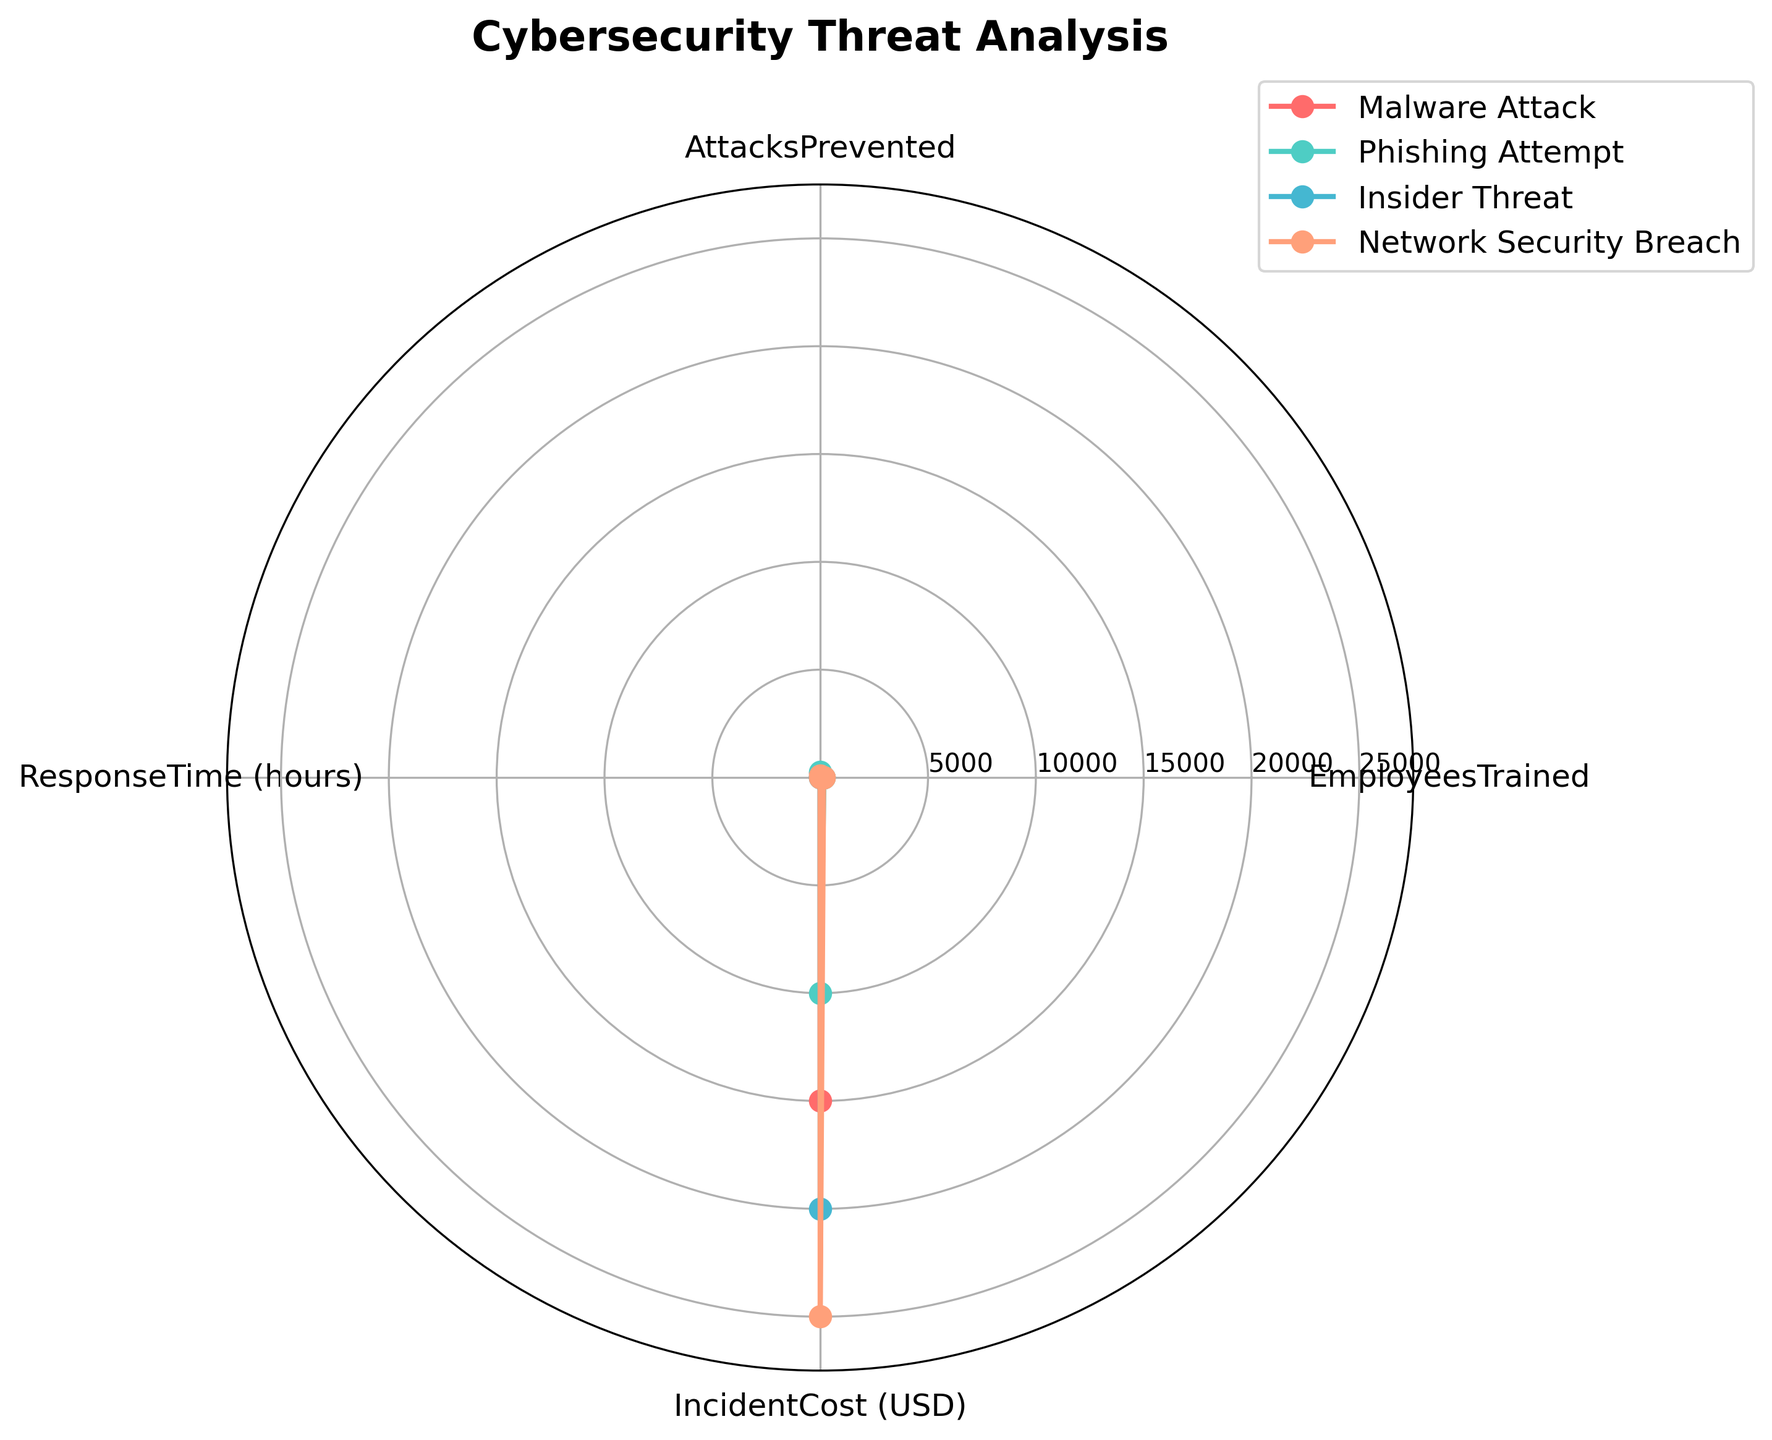What's the title of the figure? The title of the figure is usually found at the top of the chart. By looking at the rendered figure, you can note the title.
Answer: Cybersecurity Threat Analysis How many threat types are represented in the radar chart? The radar chart includes lines or shapes for each threat type, and each threat type is labeled in the legend. By counting these labels, you can determine the number of threat types.
Answer: 4 Which threat type has the highest number of employees trained? By looking at the "EmployeesTrained" axis and seeing which shape or line stretches the farthest towards the outer ring, we can identify the threat type.
Answer: Phishing Attempt What's the total incident cost for all threat types combined? To find the total incident cost, sum up the values of the "IncidentCost (USD)" axis for all threat types. The individual costs are 15000, 10000, 20000, and 25000.
Answer: 70000 Which threat type has the shortest response time? By checking the "ResponseTime (hours)" axis and identifying which threat type's data point is closest to the center (indicating the shortest response time), we can find the answer.
Answer: Phishing Attempt What's the average number of attacks prevented across all threat types? To find the average number of attacks prevented, sum up the attacks prevented by all threat types and divide by the number of threat types: (200 + 250 + 60 + 100) / 4 = 610 / 4.
Answer: 152.5 How does the number of attacks prevented for Malware Attack compare to Network Security Breach? Compare the values on the "AttacksPrevented" axis for these two threat types. Malware Attack = 200 and Network Security Breach = 100.
Answer: Malware Attack has more Which threat type has the highest incident cost, and how does it compare to the lowest incident cost threat type? Identify the threat type with the highest cost on the "IncidentCost (USD)" axis and compare it with the lowest. Highest is Network Security Breach = 25000, lowest is Phishing Attempt = 10000.
Answer: Network Security Breach is 15000 more than Phishing Attempt What is the difference in the number of employees trained between the Insider Threat and the Network Security Breach? Subtract the number of employees trained for Insider Threat from the number for Network Security Breach: 160 - 120.
Answer: 40 Which threat type has the lowest number of attacks prevented, and what does this imply about its relative impact compared to other threat types? By looking at the "AttacksPrevented" axis and identifying the lowest value (Insider Threat = 60), you can infer its relative impact. This implies it may be a less frequent target or harder to prevent.
Answer: Insider Threat may be less frequent or harder to prevent 